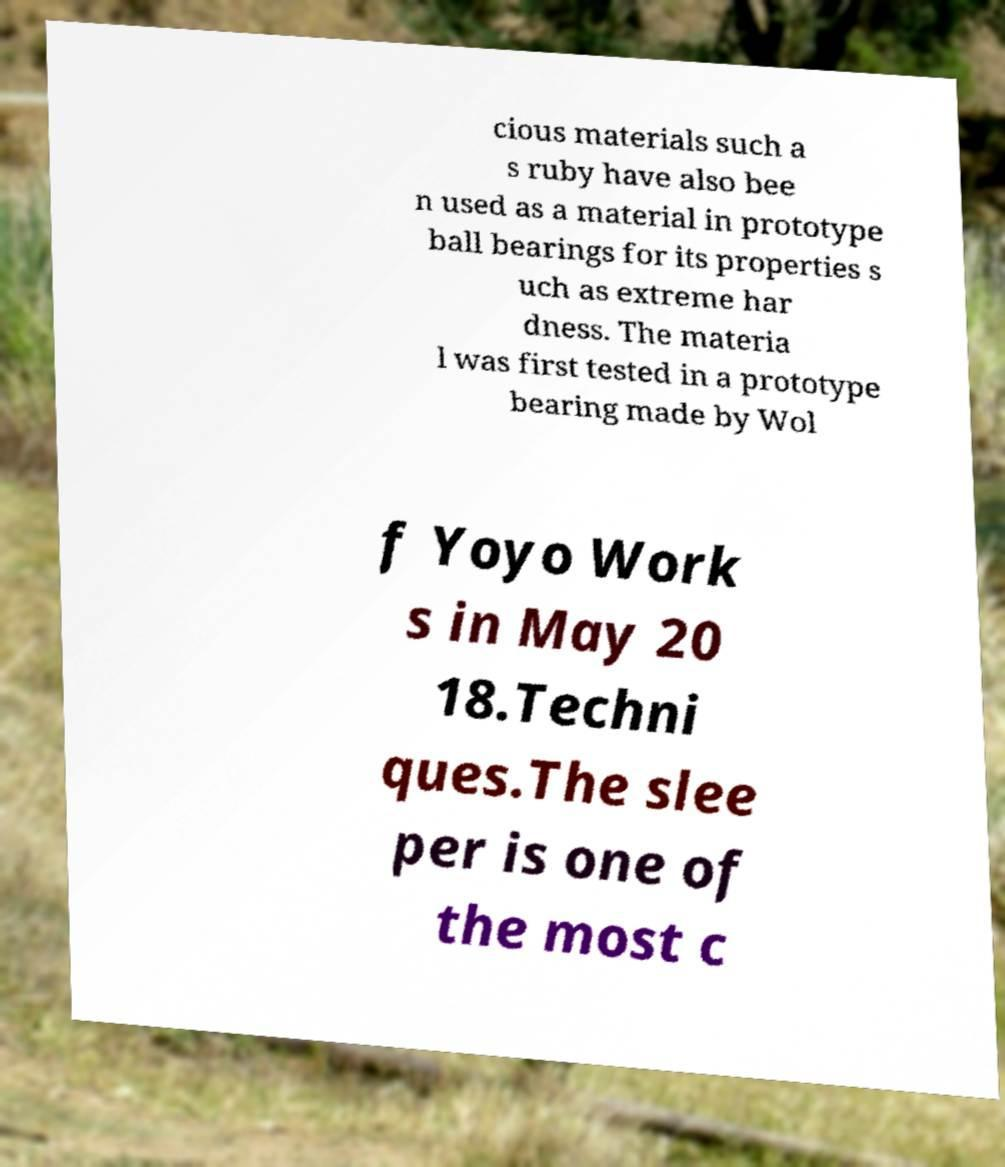I need the written content from this picture converted into text. Can you do that? cious materials such a s ruby have also bee n used as a material in prototype ball bearings for its properties s uch as extreme har dness. The materia l was first tested in a prototype bearing made by Wol f Yoyo Work s in May 20 18.Techni ques.The slee per is one of the most c 